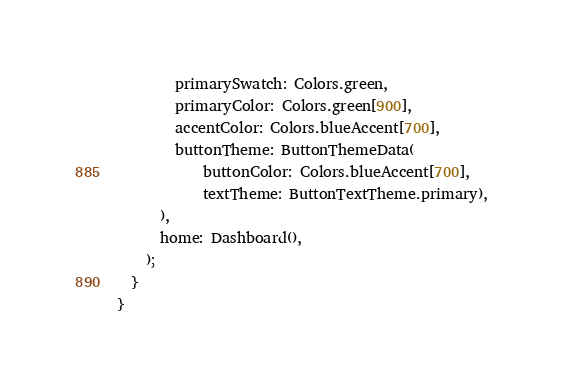Convert code to text. <code><loc_0><loc_0><loc_500><loc_500><_Dart_>        primarySwatch: Colors.green,
        primaryColor: Colors.green[900],
        accentColor: Colors.blueAccent[700],
        buttonTheme: ButtonThemeData(
            buttonColor: Colors.blueAccent[700],
            textTheme: ButtonTextTheme.primary),
      ),
      home: Dashboard(),
    );
  }
}
</code> 